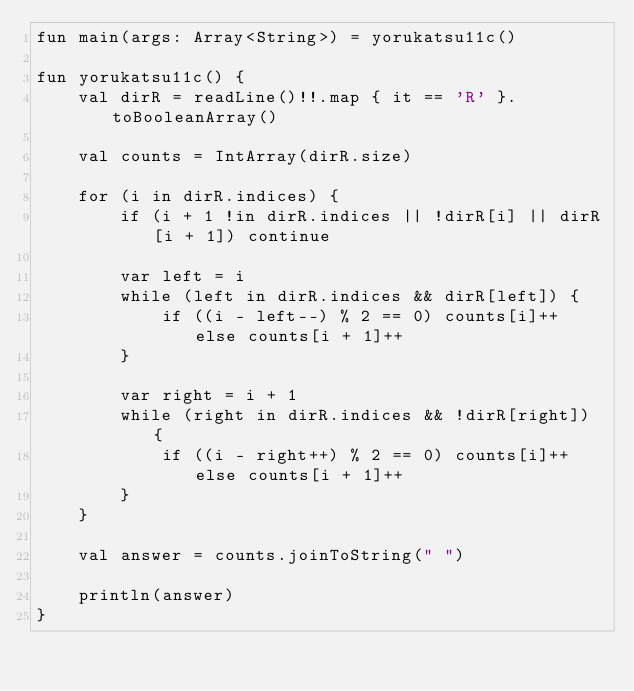<code> <loc_0><loc_0><loc_500><loc_500><_Kotlin_>fun main(args: Array<String>) = yorukatsu11c()

fun yorukatsu11c() {
    val dirR = readLine()!!.map { it == 'R' }.toBooleanArray()

    val counts = IntArray(dirR.size)

    for (i in dirR.indices) {
        if (i + 1 !in dirR.indices || !dirR[i] || dirR[i + 1]) continue

        var left = i
        while (left in dirR.indices && dirR[left]) {
            if ((i - left--) % 2 == 0) counts[i]++ else counts[i + 1]++
        }

        var right = i + 1
        while (right in dirR.indices && !dirR[right]) {
            if ((i - right++) % 2 == 0) counts[i]++ else counts[i + 1]++
        }
    }

    val answer = counts.joinToString(" ")

    println(answer)
}
</code> 